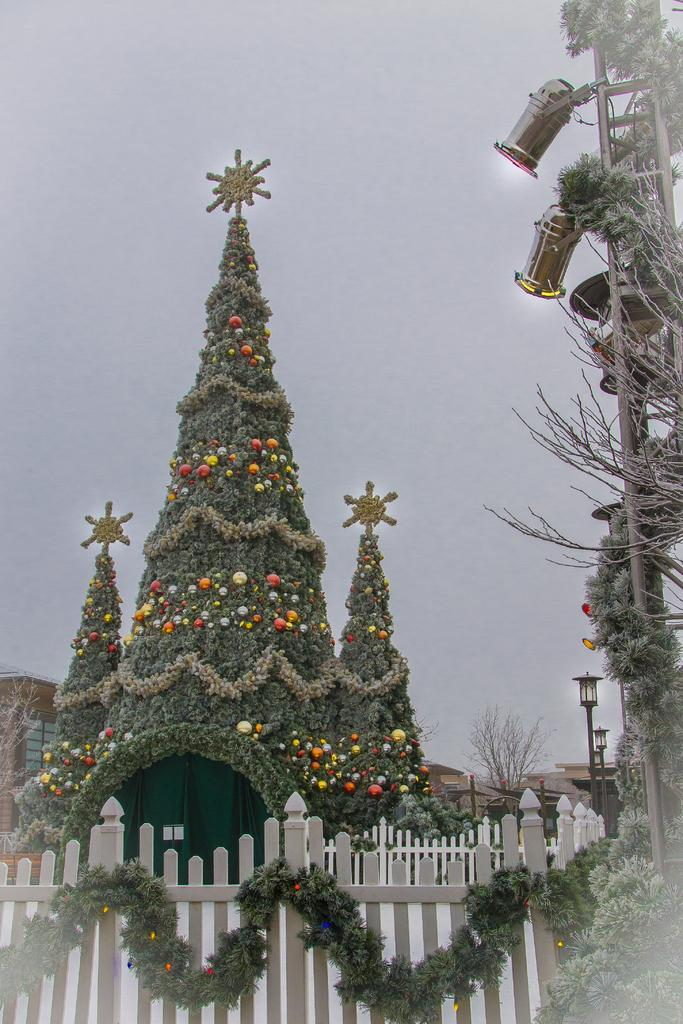What type of structure can be seen in the image? There is a fence in the image. Are there any other structures visible? Yes, there is another fence and a house in the image. What can be seen on the house? The house is decorated with something. What is visible in the background of the image? The sky is visible in the background of the image. Are there any light sources in the image? Yes, there are lights in the image. What type of pets can be seen playing in the air in the image? There are no pets visible in the image, and there is no indication of them playing in the air. 